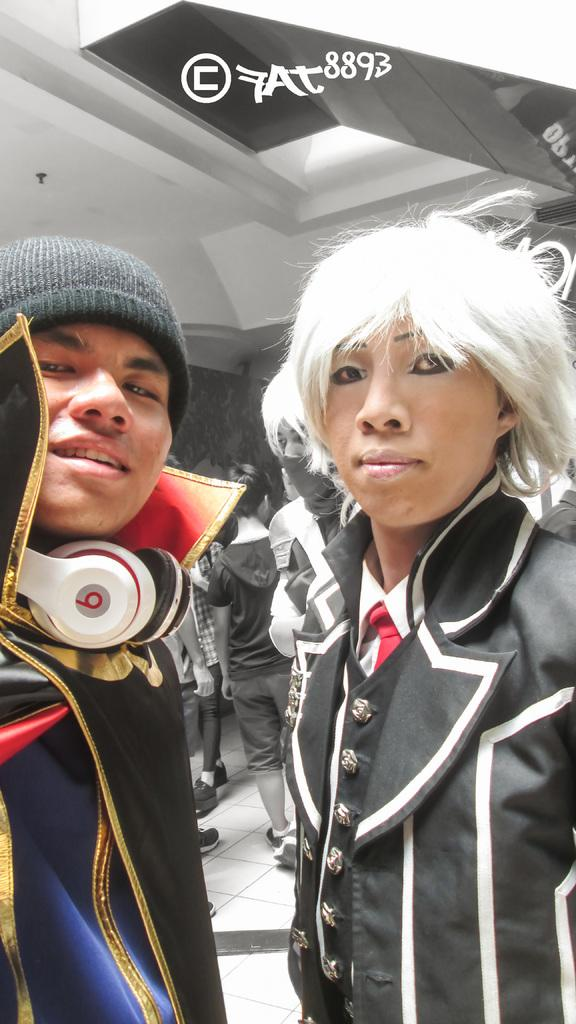How many people are visible in the image? There are two persons standing in the image. What can be seen in the background of the image? There is a group of people in the background of the image. Is there any additional information or marking on the image? Yes, the image appears to have a watermark. How many sheep are visible in the image? There are no sheep present in the image. What type of wool is being used to create the knot in the image? There is no knot or wool present in the image. 